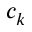<formula> <loc_0><loc_0><loc_500><loc_500>c _ { k }</formula> 